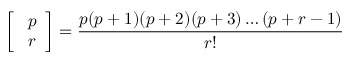<formula> <loc_0><loc_0><loc_500><loc_500>{ \left [ \begin{array} { l } { p } \\ { r } \end{array} \right ] } = { \frac { p ( p + 1 ) ( p + 2 ) ( p + 3 ) \dots ( p + r - 1 ) } { r ! } }</formula> 